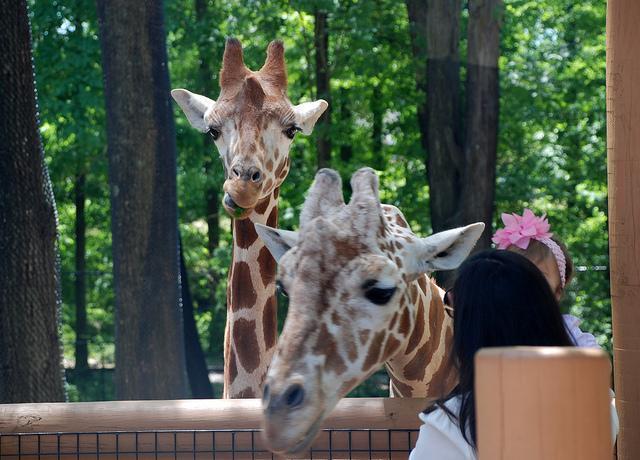How many giraffes are in the photo?
Give a very brief answer. 2. How many giraffes are visible?
Give a very brief answer. 2. How many people are in the photo?
Give a very brief answer. 2. 